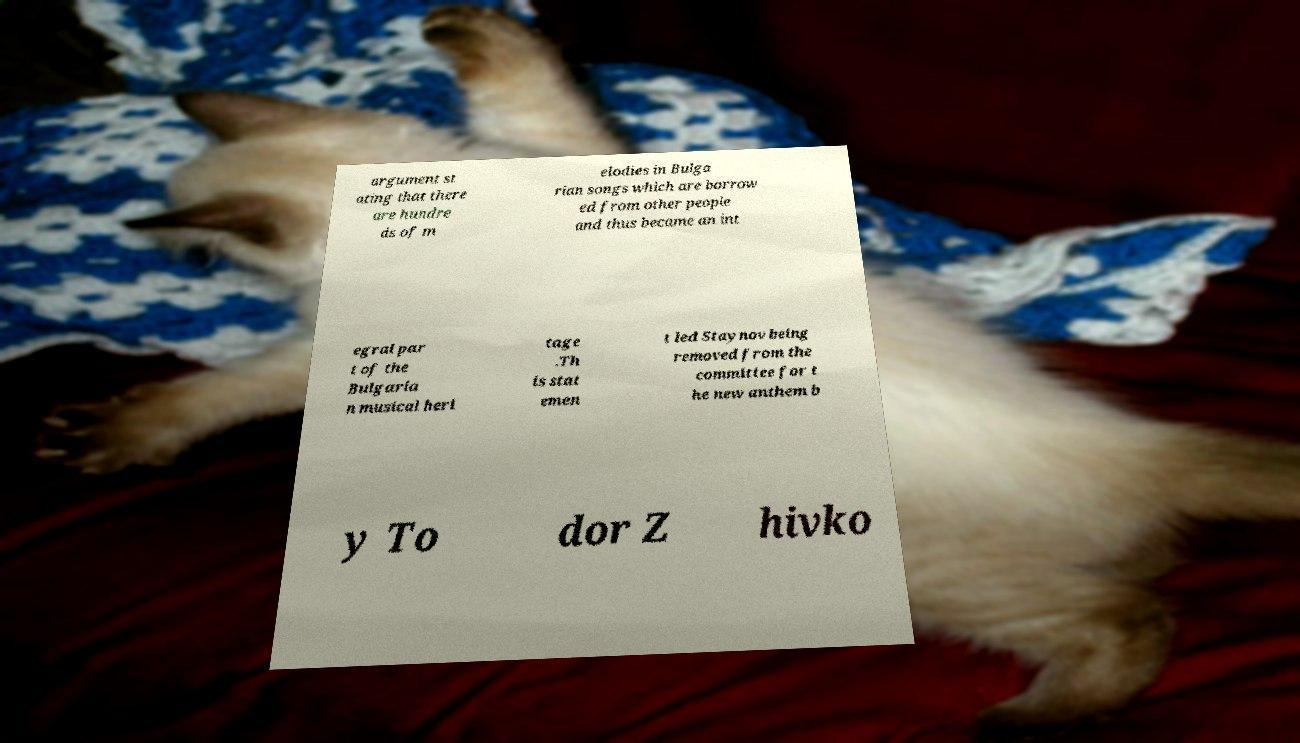Please read and relay the text visible in this image. What does it say? argument st ating that there are hundre ds of m elodies in Bulga rian songs which are borrow ed from other people and thus became an int egral par t of the Bulgaria n musical heri tage .Th is stat emen t led Staynov being removed from the committee for t he new anthem b y To dor Z hivko 